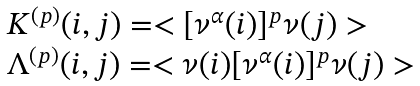<formula> <loc_0><loc_0><loc_500><loc_500>\begin{array} { l } { K ^ { ( p ) } ( i , j ) = < [ \nu ^ { \alpha } ( i ) ] ^ { p } \nu ( j ) > } \\ { \Lambda ^ { ( p ) } ( i , j ) = < \nu ( i ) [ \nu ^ { \alpha } ( i ) ] ^ { p } \nu ( j ) > } \end{array}</formula> 